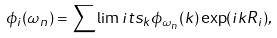Convert formula to latex. <formula><loc_0><loc_0><loc_500><loc_500>\phi _ { i } ( \omega _ { n } ) = \sum \lim i t s _ { k } \phi _ { \omega _ { n } } ( { k } ) \exp ( i { k } { R } _ { i } ) ,</formula> 